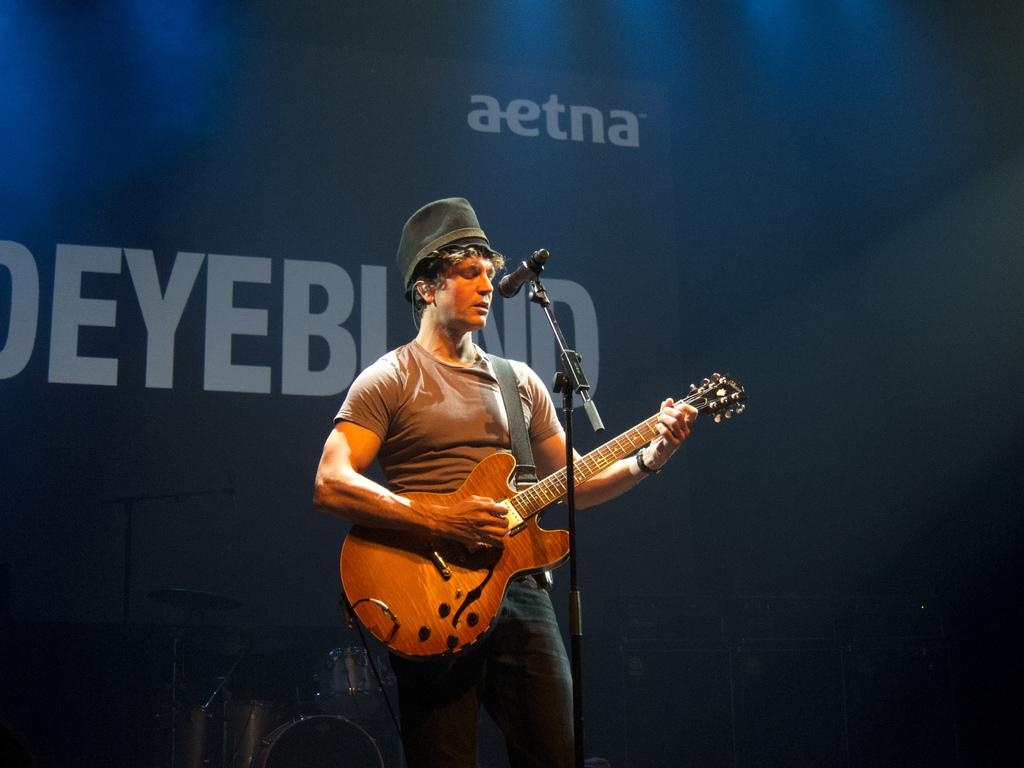What is the person in the image wearing? The person is wearing a brown t-shirt and black pants. What is the person holding in the image? The person is holding a guitar. What is the person doing with the guitar? The person is playing the guitar. What is the person standing in front of? The person is standing in front of a microphone. What can be seen in the background of the image? There is a blue poster in the background. How many dolls are sitting on the rice in the image? There are no dolls or rice present in the image. What type of umbrella is the person holding while playing the guitar? The person is not holding an umbrella in the image; they are holding a guitar. 